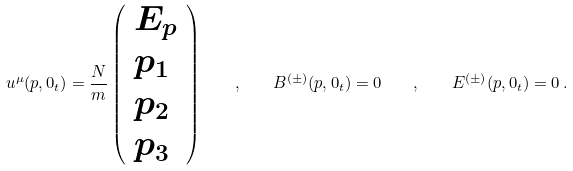<formula> <loc_0><loc_0><loc_500><loc_500>u ^ { \mu } ( { p } , 0 _ { t } ) = { \frac { N } { m } } \left ( \begin{array} { l } { { E _ { p } } } \\ { { p _ { 1 } } } \\ { { p _ { 2 } } } \\ { { p _ { 3 } } } \end{array} \right ) \quad , \quad B ^ { ( \pm ) } ( { p } , 0 _ { t } ) = { 0 } \quad , \quad E ^ { ( \pm ) } ( { p } , 0 _ { t } ) = { 0 } \, .</formula> 